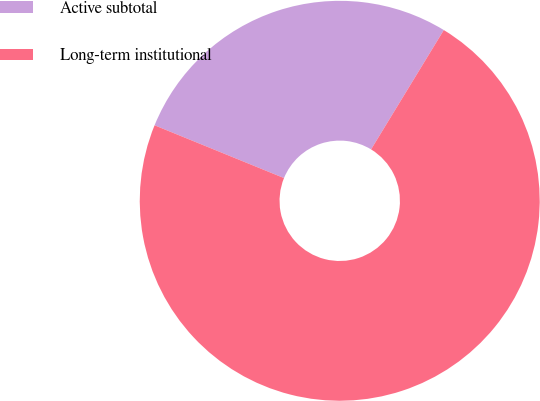Convert chart to OTSL. <chart><loc_0><loc_0><loc_500><loc_500><pie_chart><fcel>Active subtotal<fcel>Long-term institutional<nl><fcel>27.55%<fcel>72.45%<nl></chart> 